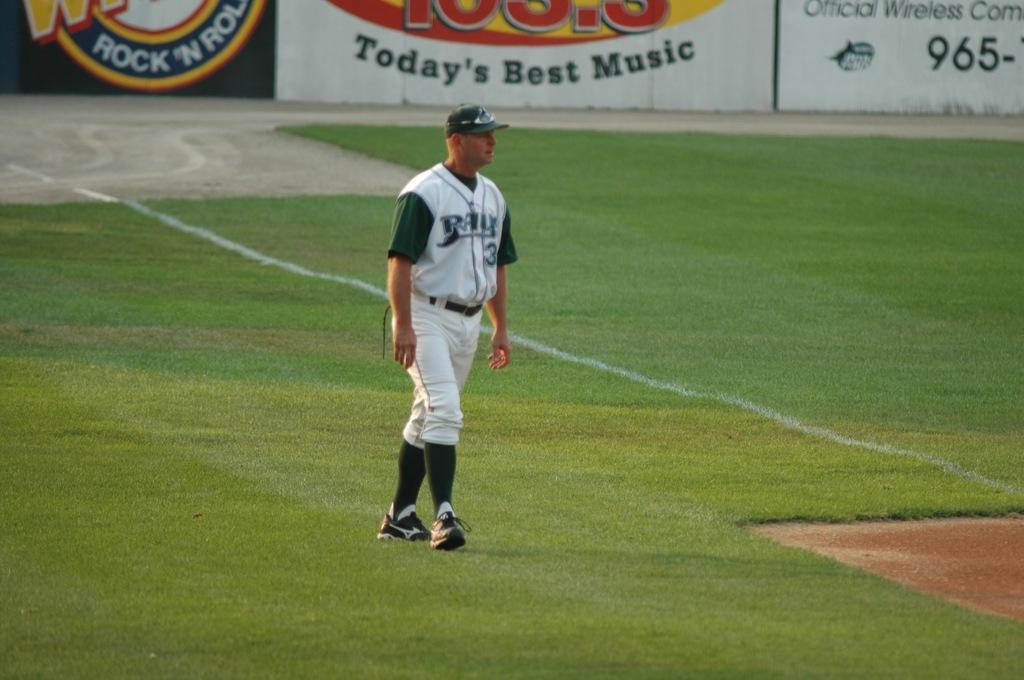<image>
Give a short and clear explanation of the subsequent image. A man wearing a Rays baseball uniform is walking on the field. 